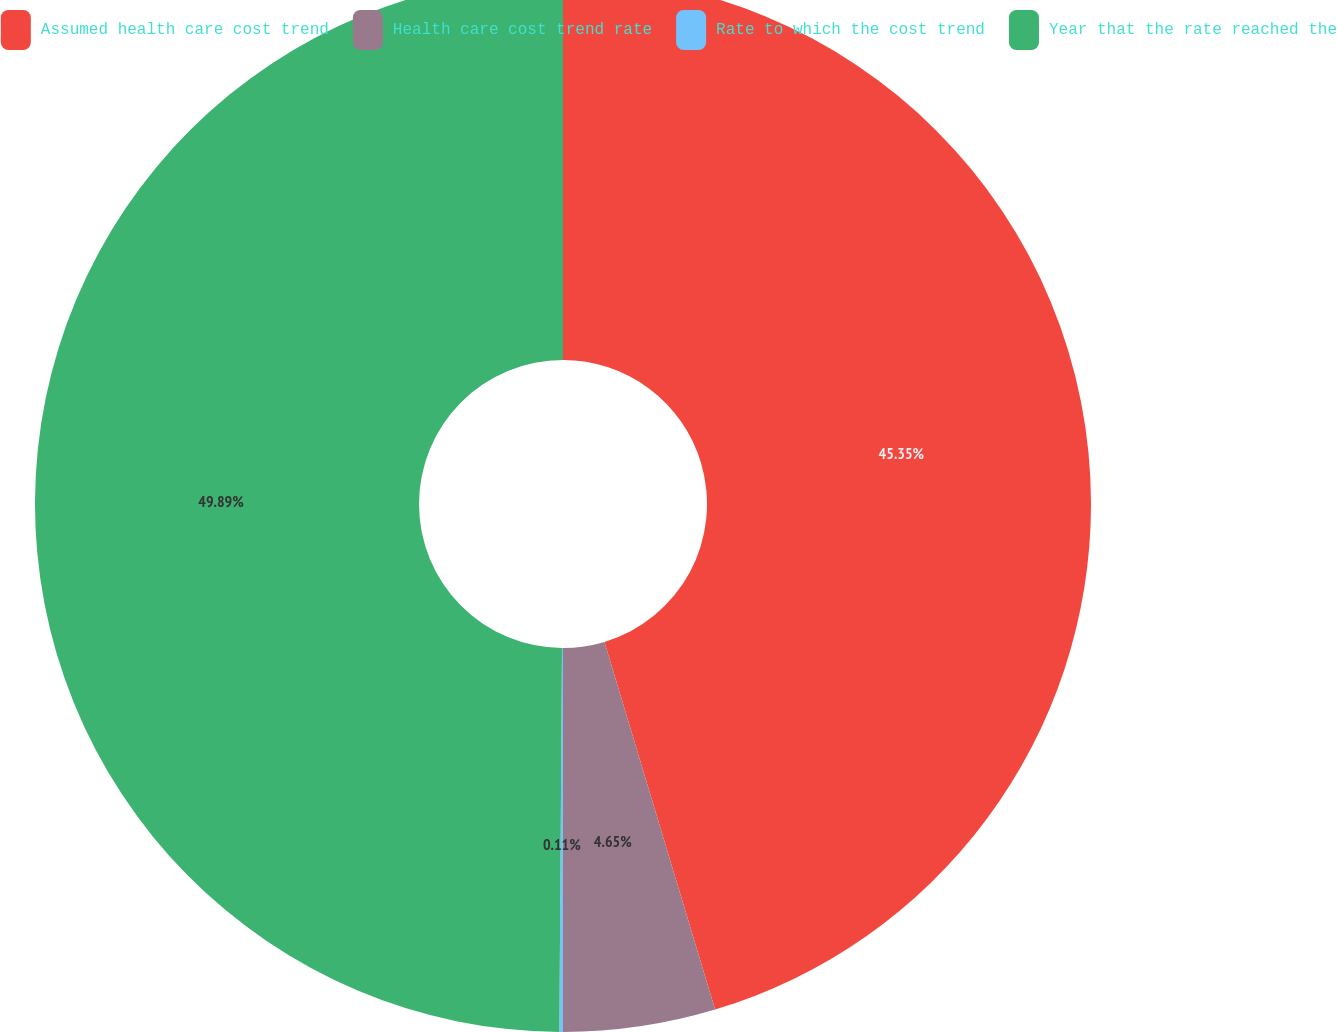Convert chart. <chart><loc_0><loc_0><loc_500><loc_500><pie_chart><fcel>Assumed health care cost trend<fcel>Health care cost trend rate<fcel>Rate to which the cost trend<fcel>Year that the rate reached the<nl><fcel>45.35%<fcel>4.65%<fcel>0.11%<fcel>49.89%<nl></chart> 